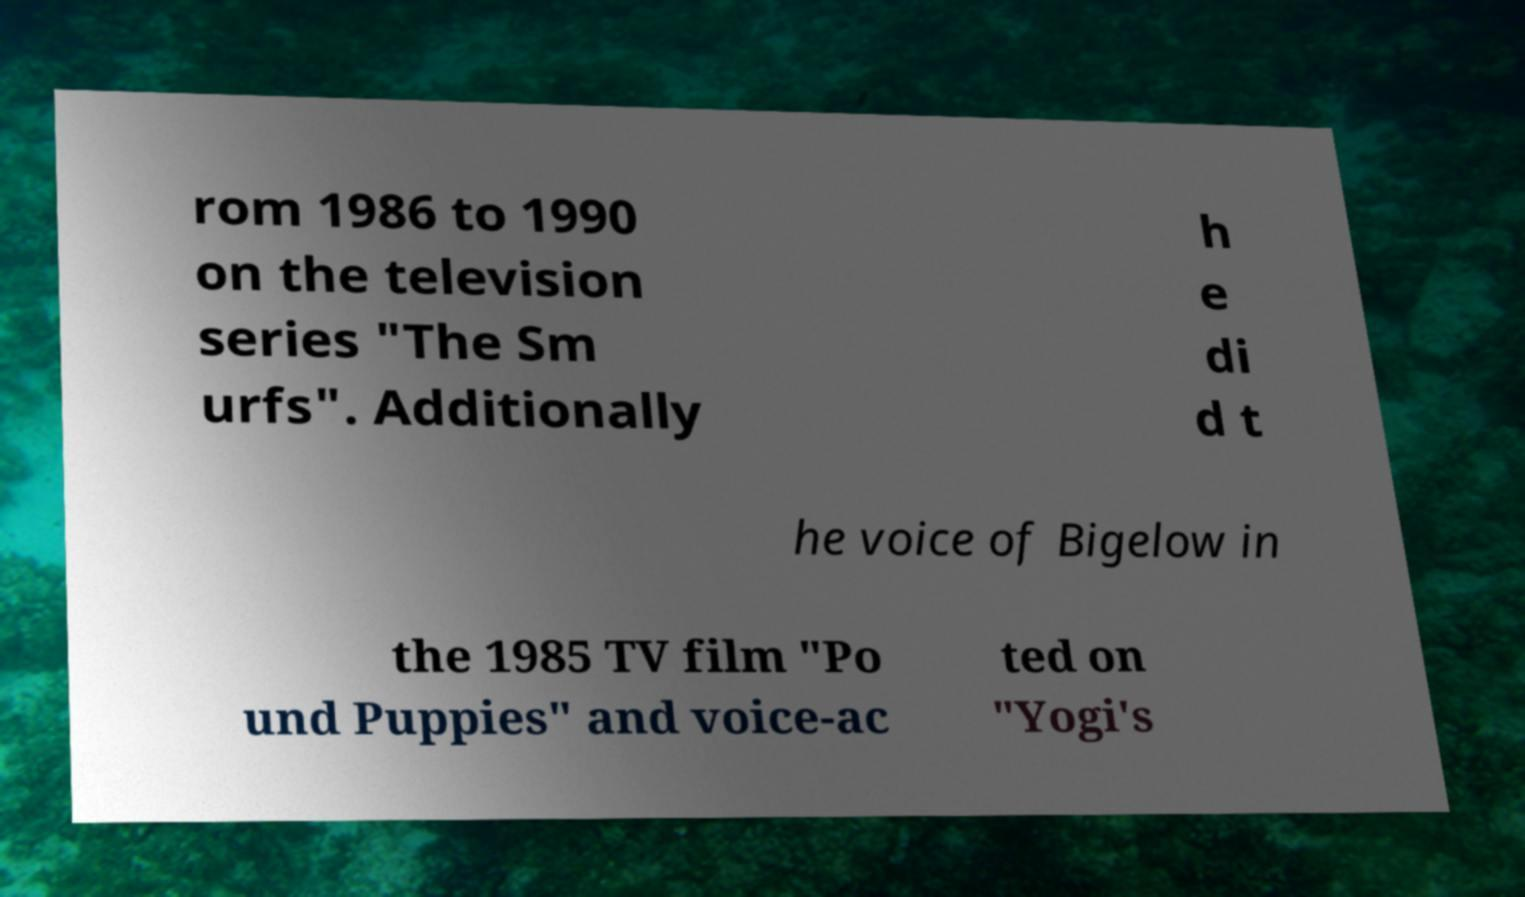For documentation purposes, I need the text within this image transcribed. Could you provide that? rom 1986 to 1990 on the television series "The Sm urfs". Additionally h e di d t he voice of Bigelow in the 1985 TV film "Po und Puppies" and voice-ac ted on "Yogi's 